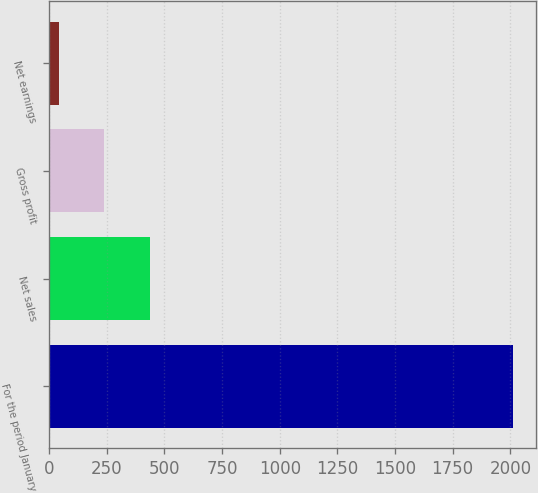Convert chart to OTSL. <chart><loc_0><loc_0><loc_500><loc_500><bar_chart><fcel>For the period January<fcel>Net sales<fcel>Gross profit<fcel>Net earnings<nl><fcel>2012<fcel>436.16<fcel>239.18<fcel>42.2<nl></chart> 